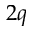<formula> <loc_0><loc_0><loc_500><loc_500>2 q</formula> 